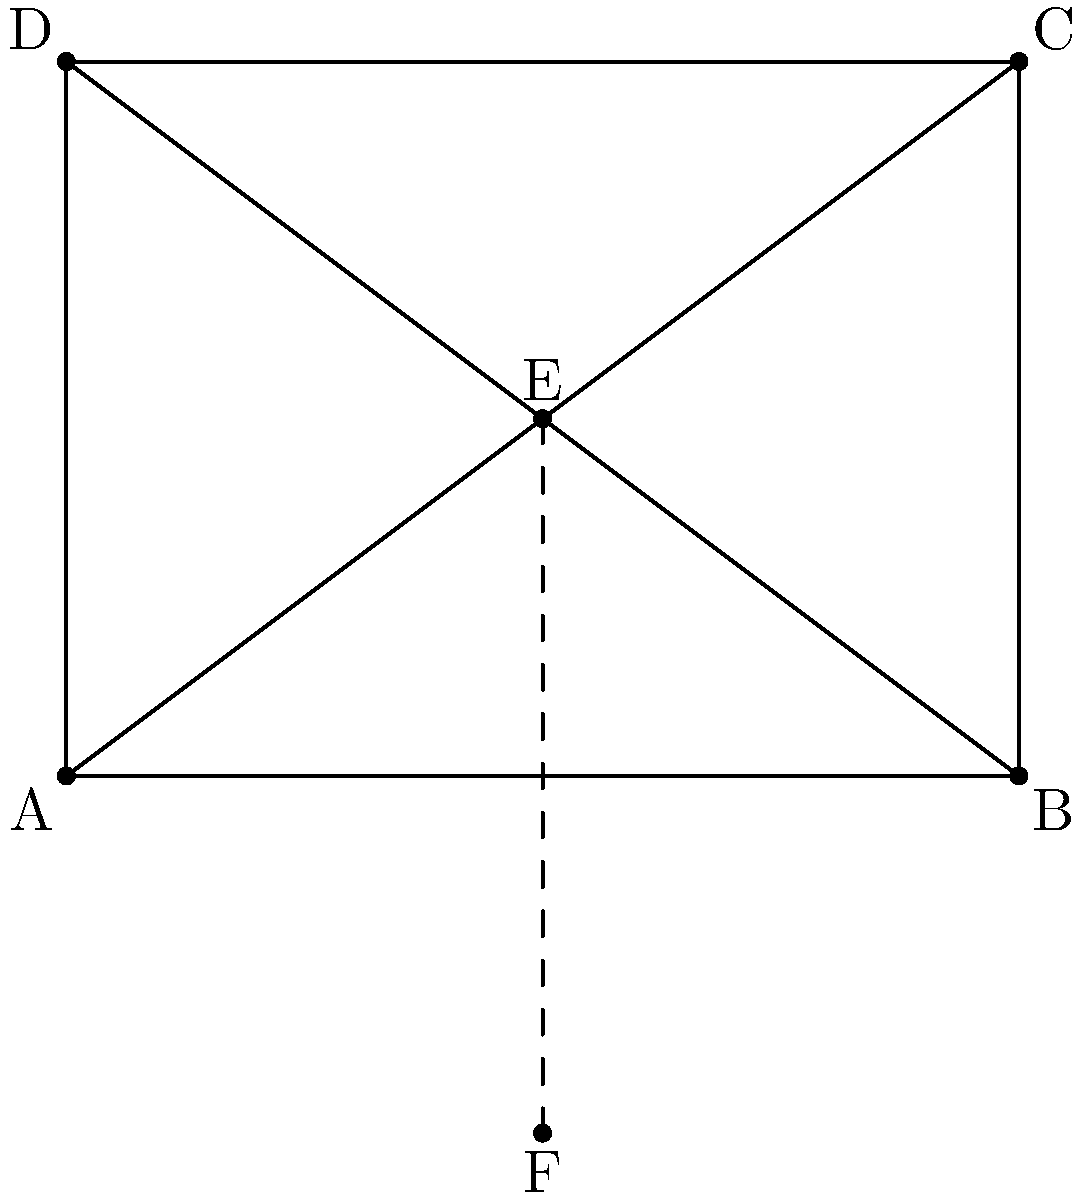In a new symmetrical development project, you plan to reflect a landscape design across an axis. The original design is represented by the triangle AEC in the diagram. What are the coordinates of point C' after reflecting triangle AEC across the x-axis (line EF)? To find the coordinates of point C' after reflecting triangle AEC across the x-axis, we follow these steps:

1. Identify the coordinates of point C:
   From the diagram, we can see that C is at (4,3).

2. Understand the reflection process:
   When reflecting a point across the x-axis, the x-coordinate remains the same, while the y-coordinate changes sign.

3. Apply the reflection:
   - The x-coordinate of C' will be the same as C: 4
   - The y-coordinate of C' will be the negative of C's y-coordinate: -3

4. Combine the new coordinates:
   C' will be at (4,-3)

This reflection creates a symmetrical design across the x-axis, which is a common technique in landscape architecture for creating balanced and visually appealing layouts in property development projects.
Answer: (4,-3) 